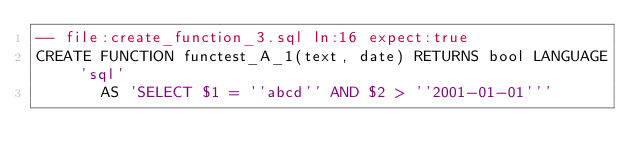Convert code to text. <code><loc_0><loc_0><loc_500><loc_500><_SQL_>-- file:create_function_3.sql ln:16 expect:true
CREATE FUNCTION functest_A_1(text, date) RETURNS bool LANGUAGE 'sql'
       AS 'SELECT $1 = ''abcd'' AND $2 > ''2001-01-01'''
</code> 